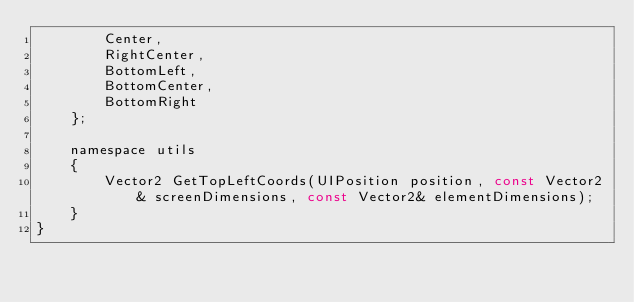<code> <loc_0><loc_0><loc_500><loc_500><_C_>        Center,
        RightCenter,
        BottomLeft,
        BottomCenter,
        BottomRight
    };

    namespace utils
    {
        Vector2 GetTopLeftCoords(UIPosition position, const Vector2& screenDimensions, const Vector2& elementDimensions);
    }
}</code> 